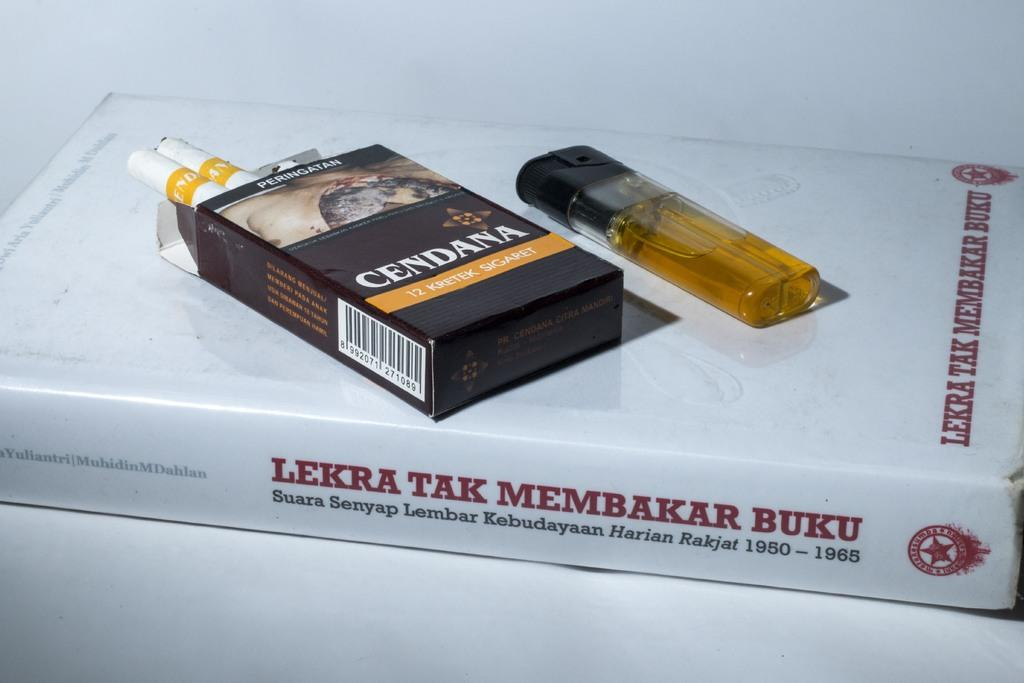Provide a one-sentence caption for the provided image. A pack of Cendana Sigaret(s) and a lighter lie on top of a copy of LEKTRA TAK MEMBAKAR BUKU. 